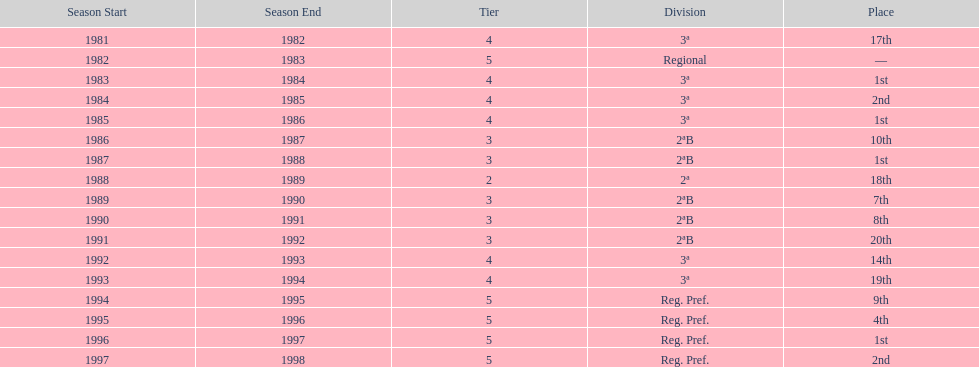Which season(s) earned first place? 1983/84, 1985/86, 1987/88, 1996/97. 